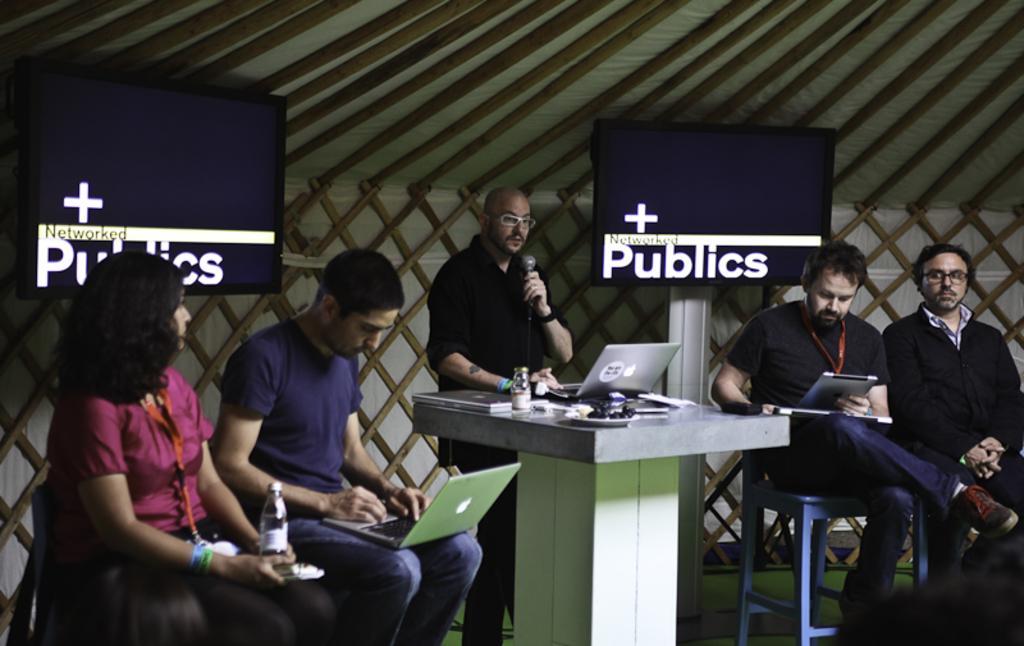Could you give a brief overview of what you see in this image? On the left there is a woman who is wearing t-shirt and jeans. She is holding a paper and water bottle, beside her we can see a man who is working on the laptop. In the centre there is a bald man who is wearing spectacles, shirt and trouser. He is holding a mic. He is standing near to the table. On the table we can see laptop, coke can, water bottle, papers and other objects. On the right there is a man who is sitting on the chair, beside him we can see another man who is looking on the tab and holding a laptop. Behind him we can see the television screen. 